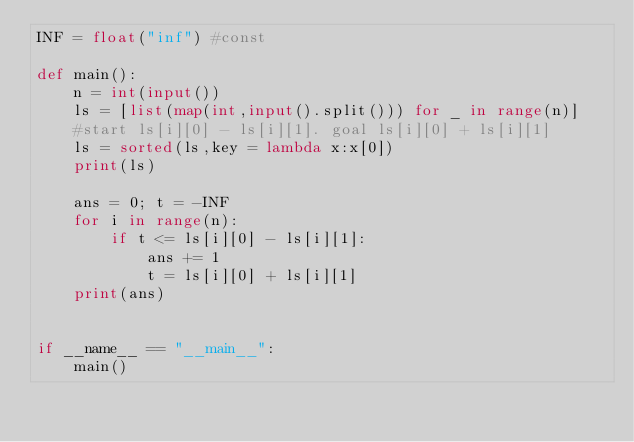<code> <loc_0><loc_0><loc_500><loc_500><_Python_>INF = float("inf") #const

def main():
    n = int(input())
    ls = [list(map(int,input().split())) for _ in range(n)]
    #start ls[i][0] - ls[i][1]. goal ls[i][0] + ls[i][1]
    ls = sorted(ls,key = lambda x:x[0])
    print(ls)

    ans = 0; t = -INF
    for i in range(n):
        if t <= ls[i][0] - ls[i][1]:
            ans += 1
            t = ls[i][0] + ls[i][1]
    print(ans)


if __name__ == "__main__":
    main()
</code> 